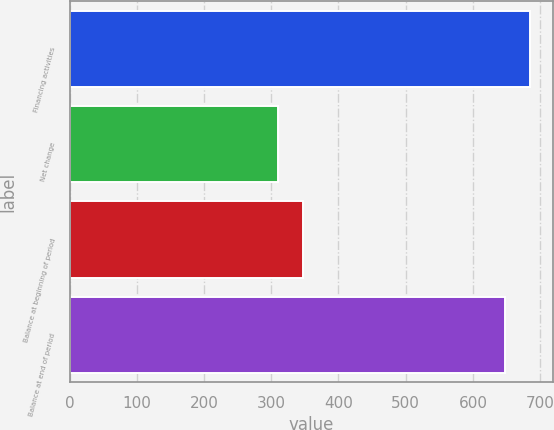<chart> <loc_0><loc_0><loc_500><loc_500><bar_chart><fcel>Financing activities<fcel>Net change<fcel>Balance at beginning of period<fcel>Balance at end of period<nl><fcel>684.7<fcel>310<fcel>346.7<fcel>648<nl></chart> 